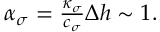<formula> <loc_0><loc_0><loc_500><loc_500>\begin{array} { r } { \alpha _ { \sigma } = \frac { \kappa _ { \sigma } } { c _ { \sigma } } \Delta h \sim 1 . } \end{array}</formula> 